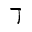<formula> <loc_0><loc_0><loc_500><loc_500>\daleth</formula> 